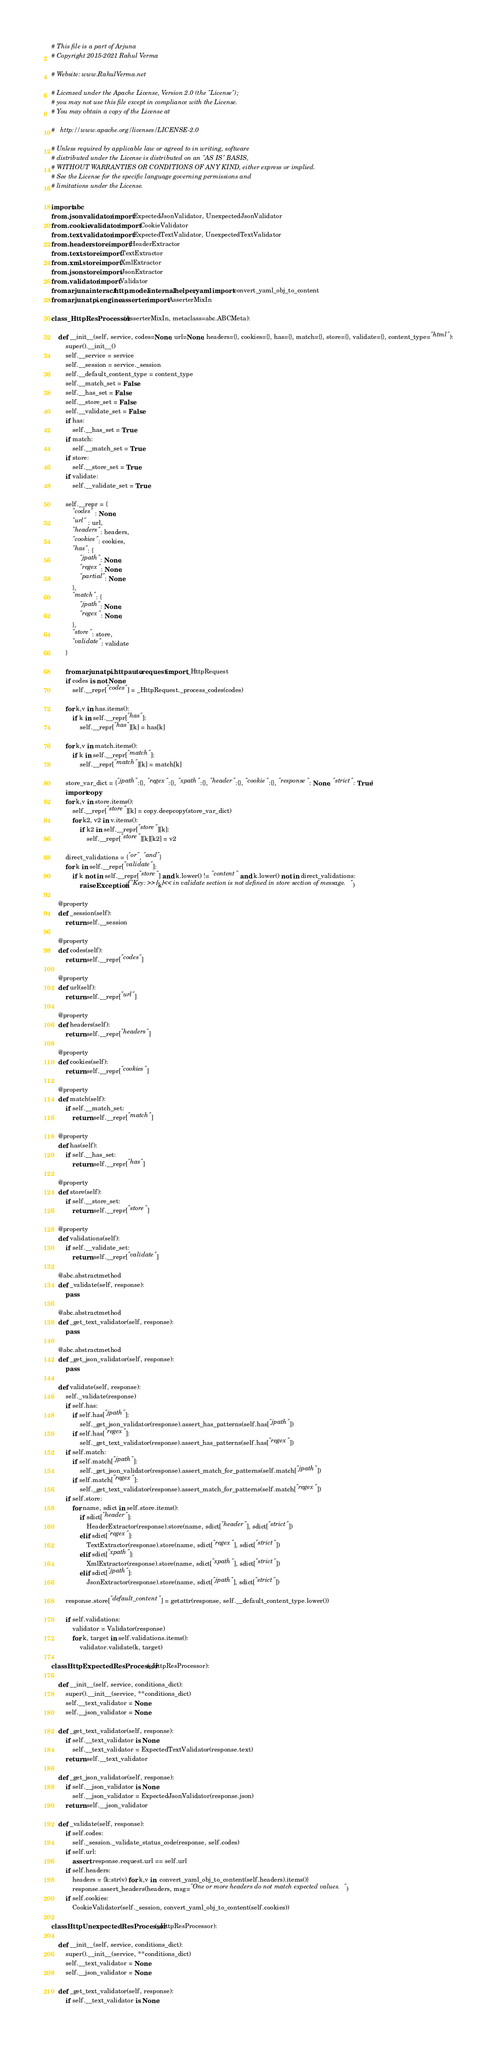<code> <loc_0><loc_0><loc_500><loc_500><_Python_># This file is a part of Arjuna
# Copyright 2015-2021 Rahul Verma

# Website: www.RahulVerma.net

# Licensed under the Apache License, Version 2.0 (the "License");
# you may not use this file except in compliance with the License.
# You may obtain a copy of the License at

#   http://www.apache.org/licenses/LICENSE-2.0

# Unless required by applicable law or agreed to in writing, software
# distributed under the License is distributed on an "AS IS" BASIS,
# WITHOUT WARRANTIES OR CONDITIONS OF ANY KIND, either express or implied.
# See the License for the specific language governing permissions and
# limitations under the License.

import abc
from .json.validator import ExpectedJsonValidator, UnexpectedJsonValidator
from .cookie.validator import CookieValidator
from .text.validator import ExpectedTextValidator, UnexpectedTextValidator
from .header.store import HeaderExtractor
from .text.store import TextExtractor
from .xml.store import XmlExtractor
from .json.store import JsonExtractor
from .validator import Validator
from arjuna.interact.http.model.internal.helper.yaml import convert_yaml_obj_to_content
from arjuna.tpi.engine.asserter import AsserterMixIn

class _HttpResProcessor(AsserterMixIn, metaclass=abc.ABCMeta):
    
    def __init__(self, service, codes=None, url=None, headers={}, cookies={}, has={}, match={}, store={}, validate={}, content_type="html"):
        super().__init__()
        self.__service = service
        self.__session = service._session
        self.__default_content_type = content_type
        self.__match_set = False
        self.__has_set = False
        self.__store_set = False
        self.__validate_set = False
        if has:
            self.__has_set = True
        if match:
            self.__match_set = True
        if store:
            self.__store_set = True
        if validate:
            self.__validate_set = True

        self.__repr = {
            "codes" : None,
            "url" : url,
            "headers": headers,
            "cookies": cookies,
            "has": {
                "jpath": None,
                "regex": None,
                "partial": None
            },
            "match": {
                "jpath": None,
                "regex": None,
            },
            "store": store,
            "validate": validate
        }

        from arjuna.tpi.httpauto.request import _HttpRequest
        if codes is not None:
            self.__repr["codes"] = _HttpRequest._process_codes(codes)

        for k,v in has.items():
            if k in self.__repr["has"]:
                self.__repr["has"][k] = has[k]   

        for k,v in match.items():
            if k in self.__repr["match"]:
                self.__repr["match"][k] = match[k]   

        store_var_dict = {"jpath":{}, "regex":{}, "xpath":{}, "header":{}, "cookie":{}, "response": None, "strict": True}
        import copy
        for k,v in store.items():
            self.__repr["store"][k] = copy.deepcopy(store_var_dict)
            for k2, v2 in v.items():
                if k2 in self.__repr["store"][k]:
                    self.__repr["store"][k][k2] = v2   

        direct_validations = {"or", "and"}
        for k in self.__repr["validate"]:
            if k not in self.__repr["store"] and k.lower() != "content" and k.lower() not in direct_validations:
                raise Exception(f"Key: >>{k}<< in validate section is not defined in store section of message.") 

    @property
    def _session(self):
        return self.__session

    @property
    def codes(self):
        return self.__repr["codes"]

    @property
    def url(self):
        return self.__repr["url"]

    @property
    def headers(self):
        return self.__repr["headers"]

    @property
    def cookies(self):
        return self.__repr["cookies"]

    @property
    def match(self):
        if self.__match_set:
            return self.__repr["match"]

    @property
    def has(self):
        if self.__has_set:
            return self.__repr["has"]

    @property
    def store(self):
        if self.__store_set:
            return self.__repr["store"]

    @property
    def validations(self):
        if self.__validate_set:
            return self.__repr["validate"]

    @abc.abstractmethod
    def _validate(self, response):
        pass

    @abc.abstractmethod
    def _get_text_validator(self, response):
        pass

    @abc.abstractmethod
    def _get_json_validator(self, response):
        pass

    def validate(self, response):
        self._validate(response)
        if self.has:
            if self.has["jpath"]:
                self._get_json_validator(response).assert_has_patterns(self.has["jpath"])
            if self.has["regex"]:
                self._get_text_validator(response).assert_has_patterns(self.has["regex"])
        if self.match:
            if self.match["jpath"]:
                self._get_json_validator(response).assert_match_for_patterns(self.match["jpath"])
            if self.match["regex"]:
                self._get_text_validator(response).assert_match_for_patterns(self.match["regex"])
        if self.store:
            for name, sdict in self.store.items():
                if sdict["header"]:
                    HeaderExtractor(response).store(name, sdict["header"], sdict["strict"])
                elif sdict["regex"]:
                    TextExtractor(response).store(name, sdict["regex"], sdict["strict"])
                elif sdict["xpath"]:
                    XmlExtractor(response).store(name, sdict["xpath"], sdict["strict"])
                elif sdict["jpath"]:
                    JsonExtractor(response).store(name, sdict["jpath"], sdict["strict"])
        
        response.store["default_content"] = getattr(response, self.__default_content_type.lower())
        
        if self.validations:
            validator = Validator(response)
            for k, target in self.validations.items():
                validator.validate(k, target)

class HttpExpectedResProcessor(_HttpResProcessor):
    
    def __init__(self, service, conditions_dict):
        super().__init__(service, **conditions_dict)
        self.__text_validator = None
        self.__json_validator = None

    def _get_text_validator(self, response):
        if self.__text_validator is None:
            self.__text_validator = ExpectedTextValidator(response.text) 
        return self.__text_validator

    def _get_json_validator(self, response):
        if self.__json_validator is None:
            self.__json_validator = ExpectedJsonValidator(response.json) 
        return self.__json_validator

    def _validate(self, response):
        if self.codes:
            self._session._validate_status_code(response, self.codes)
        if self.url:
            assert response.request.url == self.url 
        if self.headers:
            headers = {k:str(v) for k,v in  convert_yaml_obj_to_content(self.headers).items()}
            response.assert_headers(headers, msg="One or more headers do not match expected values.") 
        if self.cookies:
            CookieValidator(self._session, convert_yaml_obj_to_content(self.cookies))

class HttpUnexpectedResProcessor(_HttpResProcessor):

    def __init__(self, service, conditions_dict):
        super().__init__(service, **conditions_dict)
        self.__text_validator = None
        self.__json_validator = None

    def _get_text_validator(self, response):
        if self.__text_validator is None:</code> 